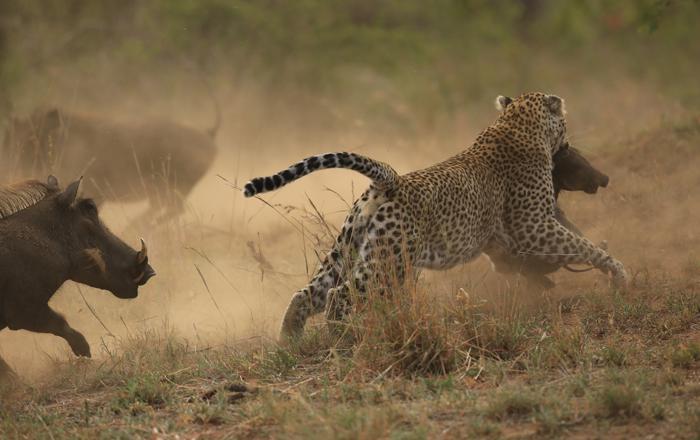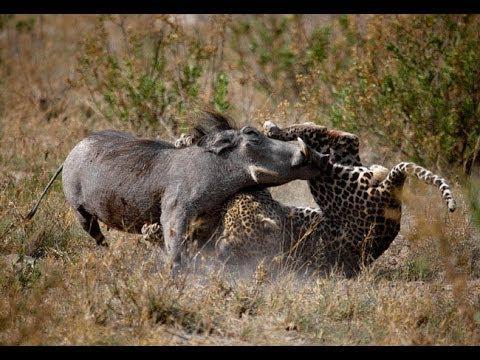The first image is the image on the left, the second image is the image on the right. For the images displayed, is the sentence "a jaguar is attacking a warthog" factually correct? Answer yes or no. Yes. The first image is the image on the left, the second image is the image on the right. Considering the images on both sides, is "A warthog is fighting with a cheetah." valid? Answer yes or no. Yes. 